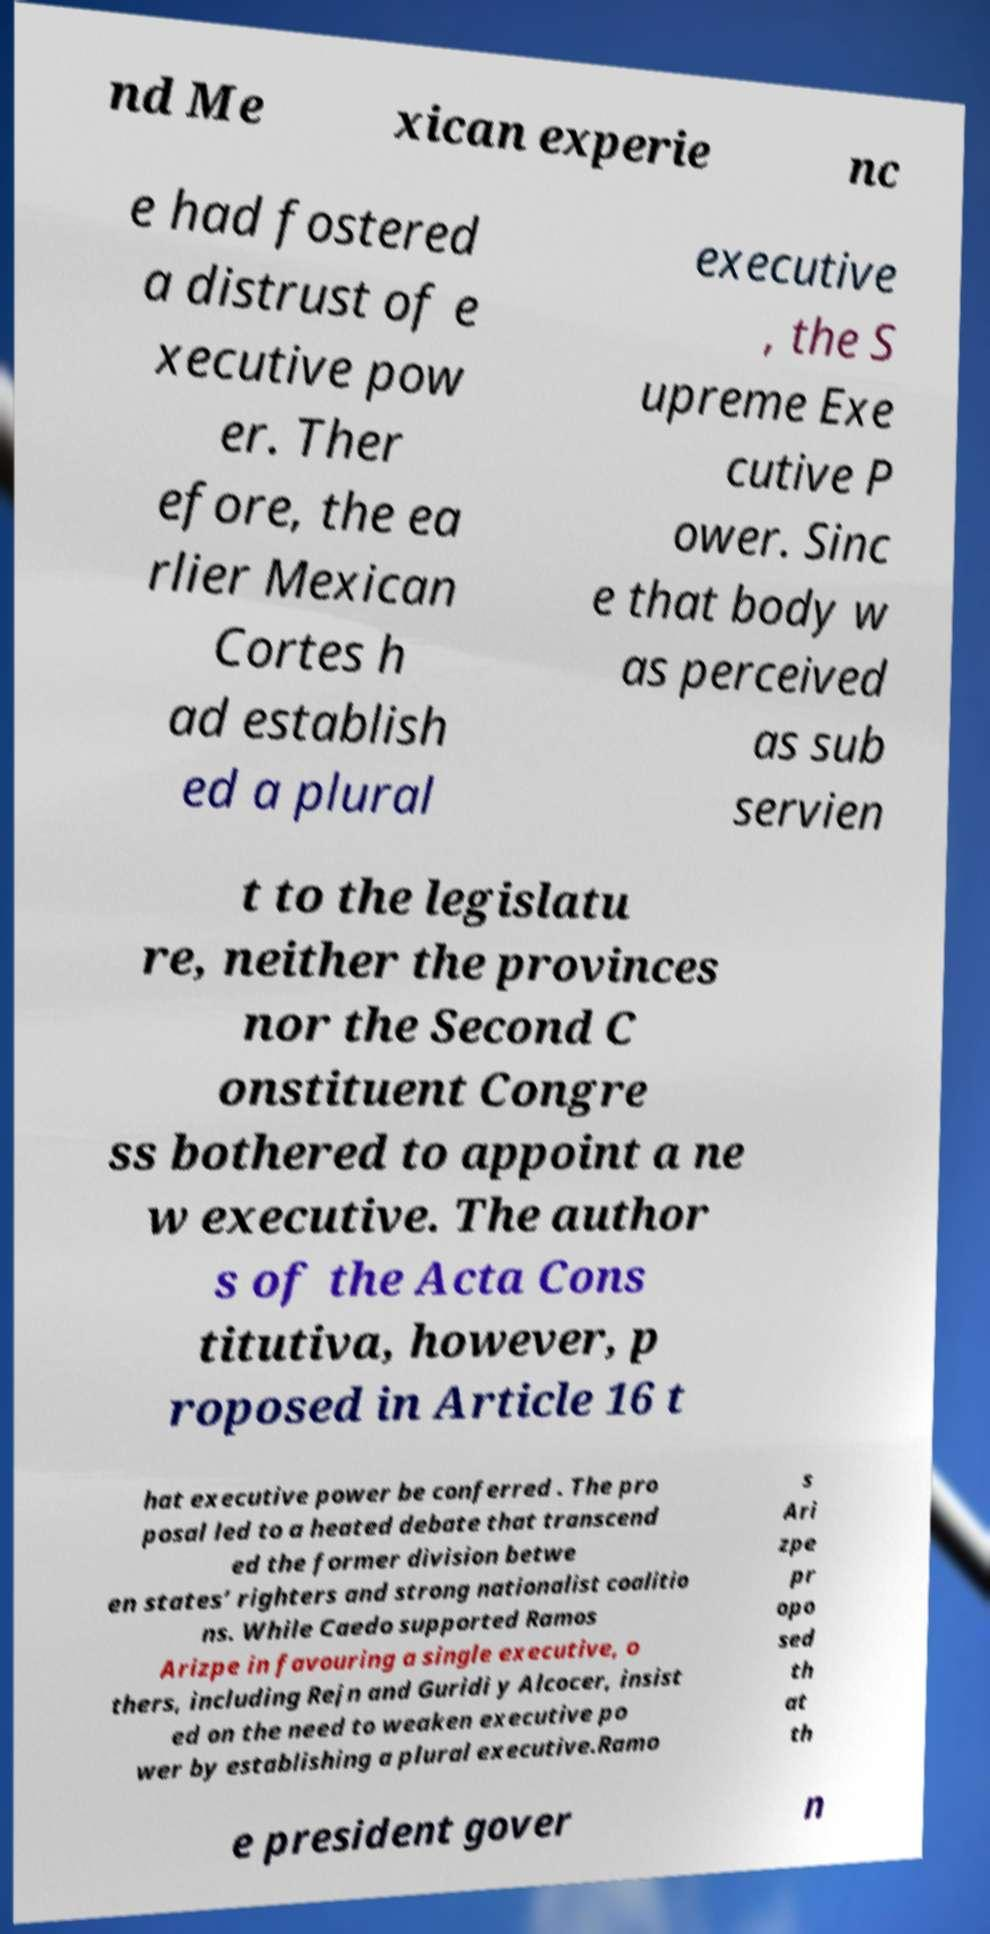For documentation purposes, I need the text within this image transcribed. Could you provide that? nd Me xican experie nc e had fostered a distrust of e xecutive pow er. Ther efore, the ea rlier Mexican Cortes h ad establish ed a plural executive , the S upreme Exe cutive P ower. Sinc e that body w as perceived as sub servien t to the legislatu re, neither the provinces nor the Second C onstituent Congre ss bothered to appoint a ne w executive. The author s of the Acta Cons titutiva, however, p roposed in Article 16 t hat executive power be conferred . The pro posal led to a heated debate that transcend ed the former division betwe en states’ righters and strong nationalist coalitio ns. While Caedo supported Ramos Arizpe in favouring a single executive, o thers, including Rejn and Guridi y Alcocer, insist ed on the need to weaken executive po wer by establishing a plural executive.Ramo s Ari zpe pr opo sed th at th e president gover n 